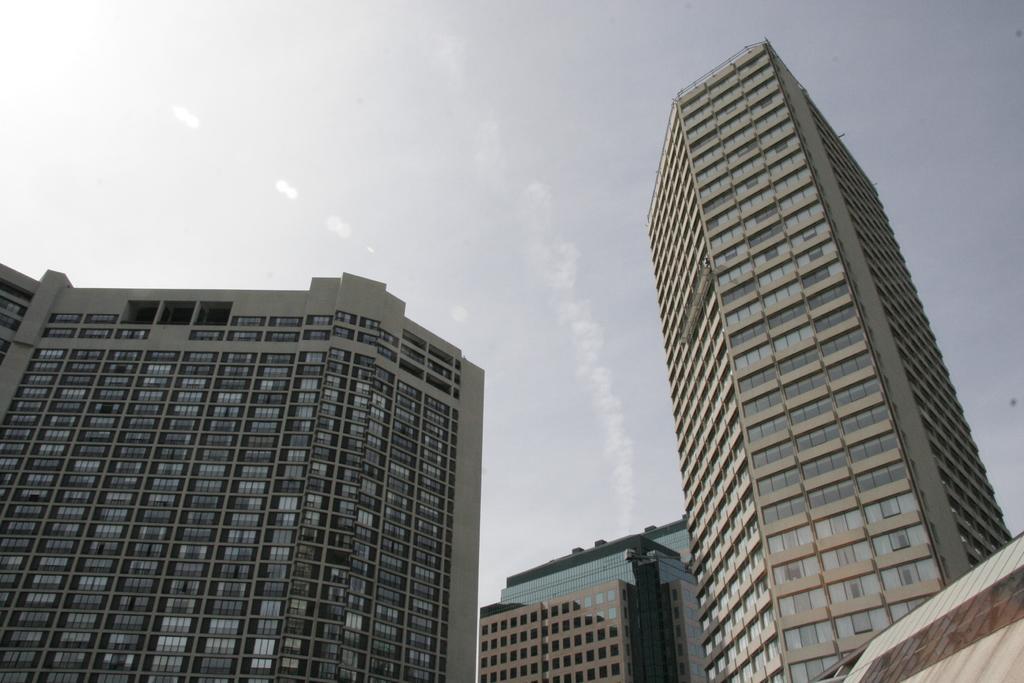Could you give a brief overview of what you see in this image? In this picture we can see buildings, there is the sky at the top of the picture, we can see glasses of these buildings. 